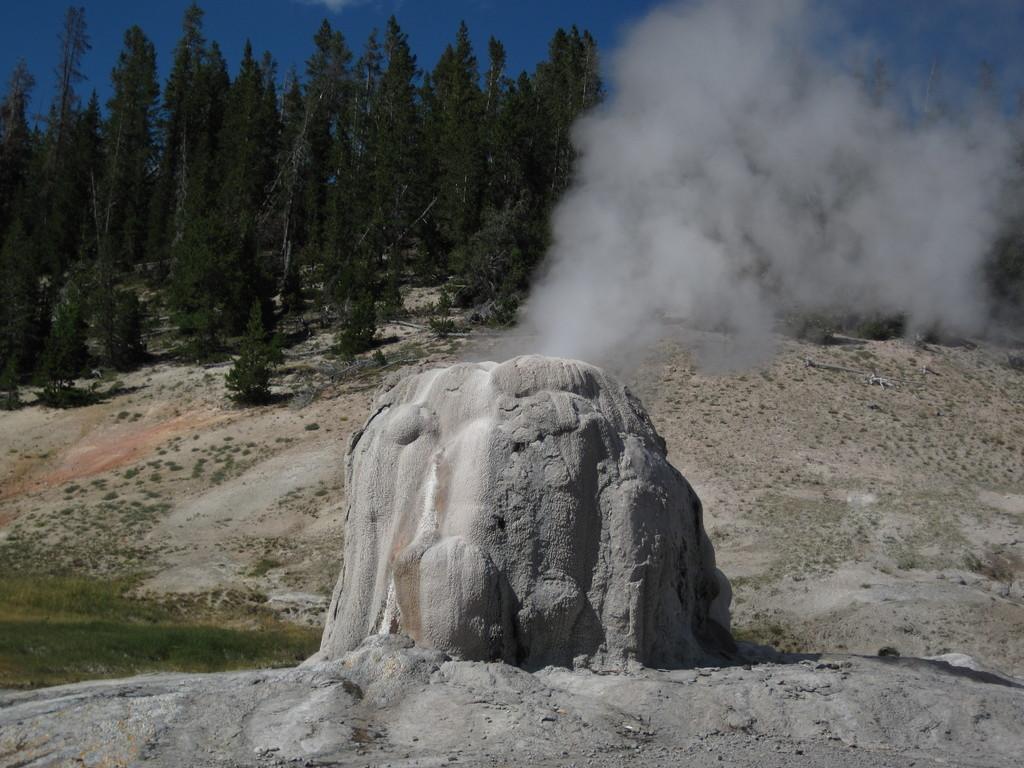In one or two sentences, can you explain what this image depicts? In this image at front there is a rock. At the background there are trees and sky. 